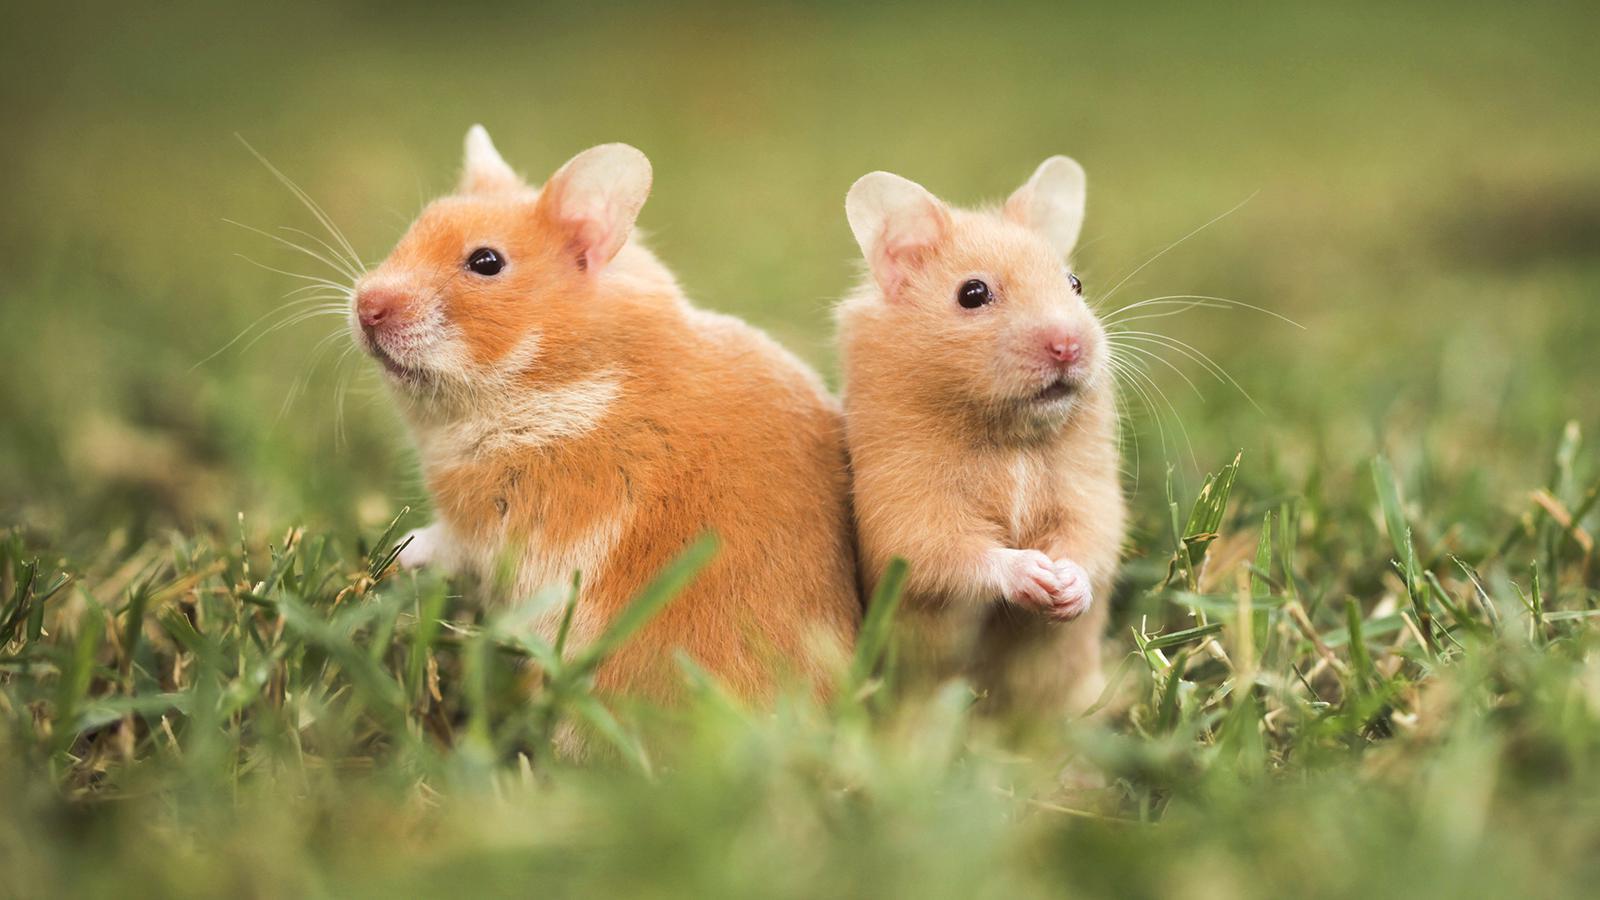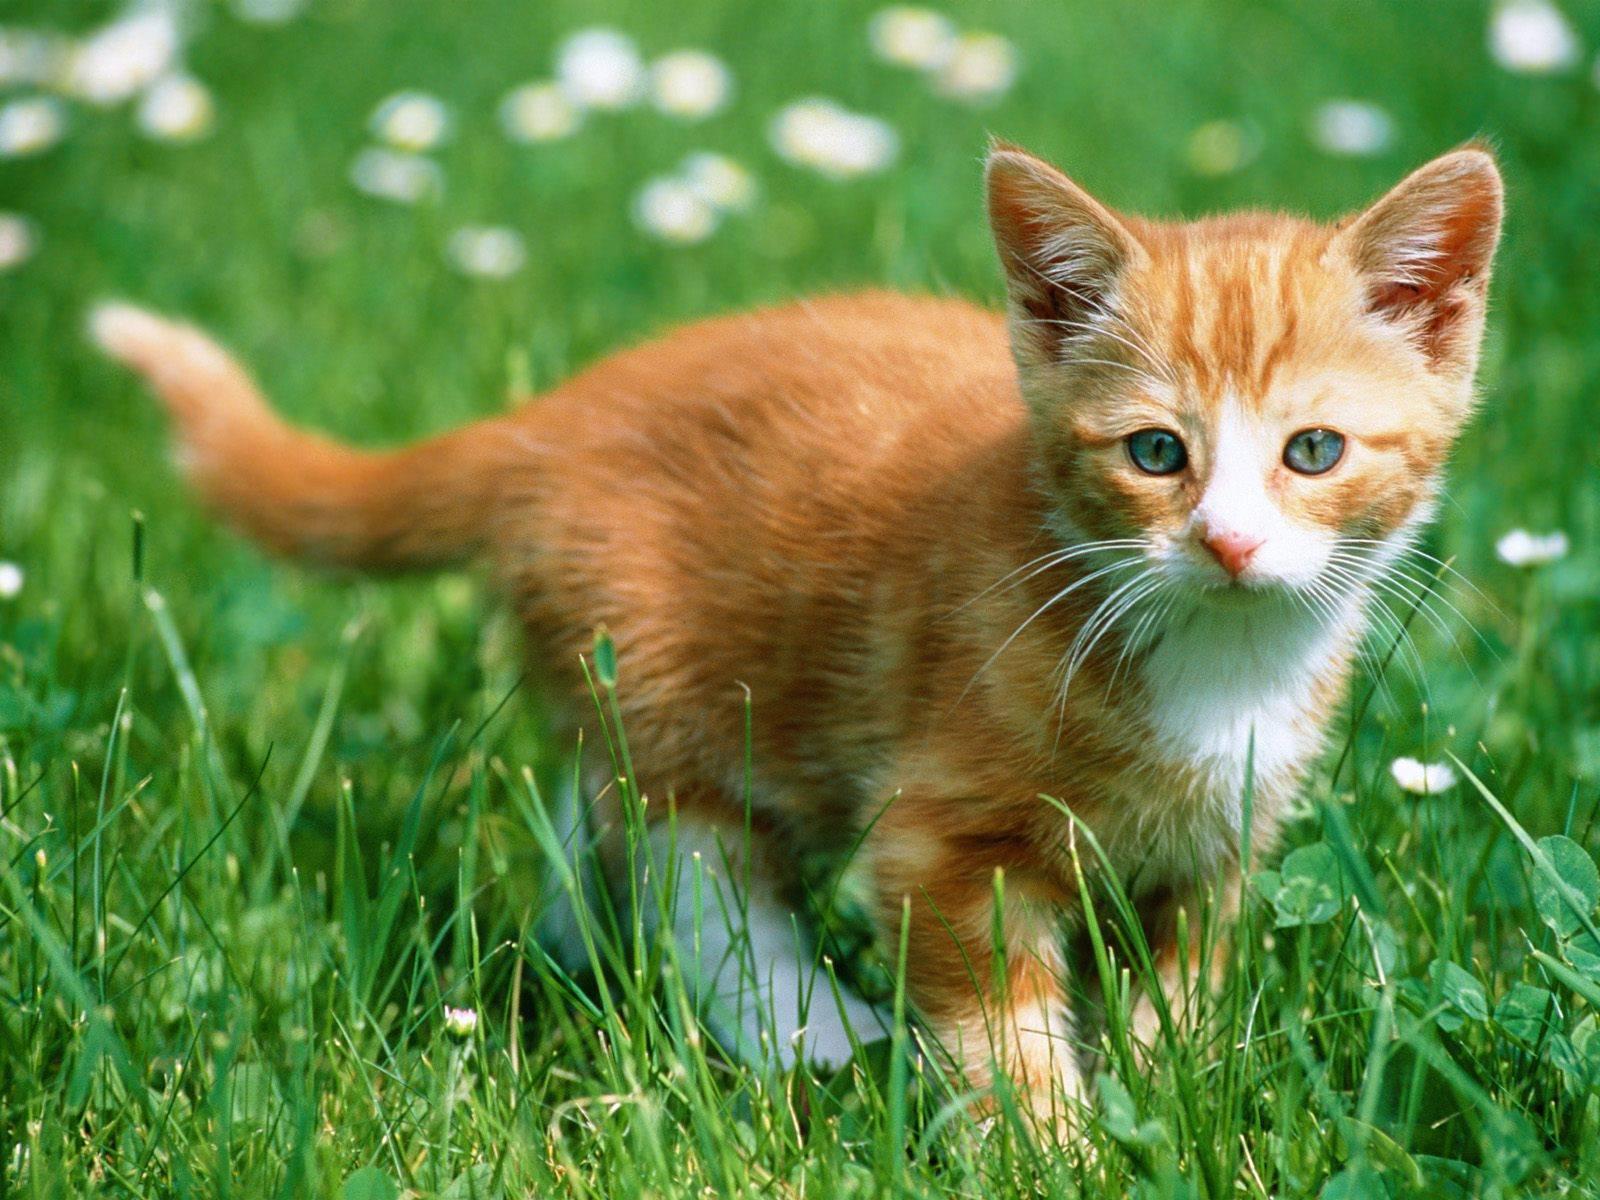The first image is the image on the left, the second image is the image on the right. Examine the images to the left and right. Is the description "in one image a hamster with a black stomach is standing in grass and looking to the left" accurate? Answer yes or no. No. 